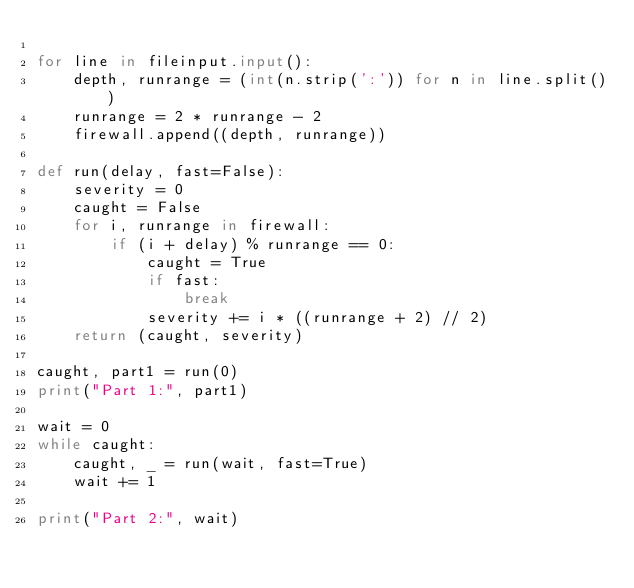<code> <loc_0><loc_0><loc_500><loc_500><_Python_>
for line in fileinput.input():
    depth, runrange = (int(n.strip(':')) for n in line.split())
    runrange = 2 * runrange - 2
    firewall.append((depth, runrange))

def run(delay, fast=False):
    severity = 0
    caught = False
    for i, runrange in firewall:
        if (i + delay) % runrange == 0:
            caught = True
            if fast:
                break
            severity += i * ((runrange + 2) // 2)
    return (caught, severity)

caught, part1 = run(0)
print("Part 1:", part1)

wait = 0
while caught:
    caught, _ = run(wait, fast=True)
    wait += 1

print("Part 2:", wait)</code> 